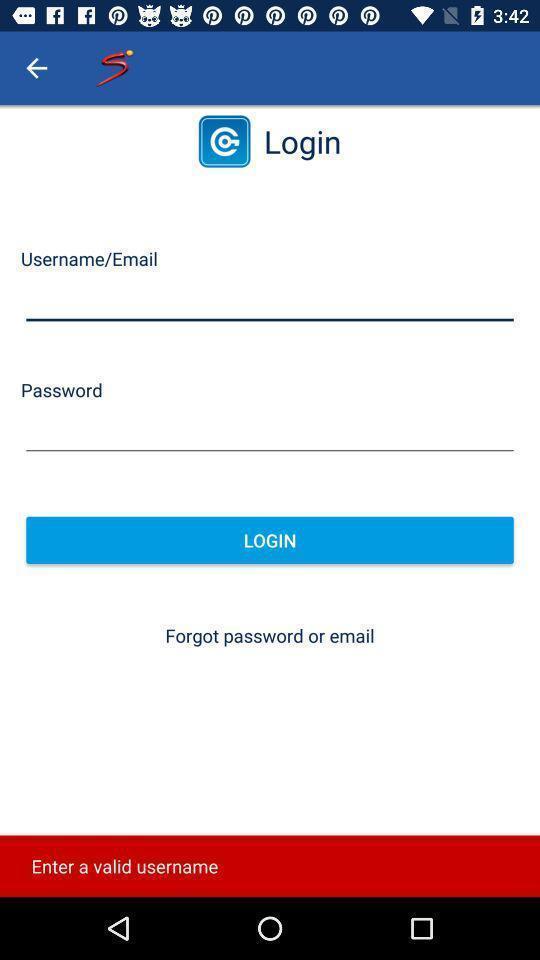Summarize the information in this screenshot. Login page of sports application. 